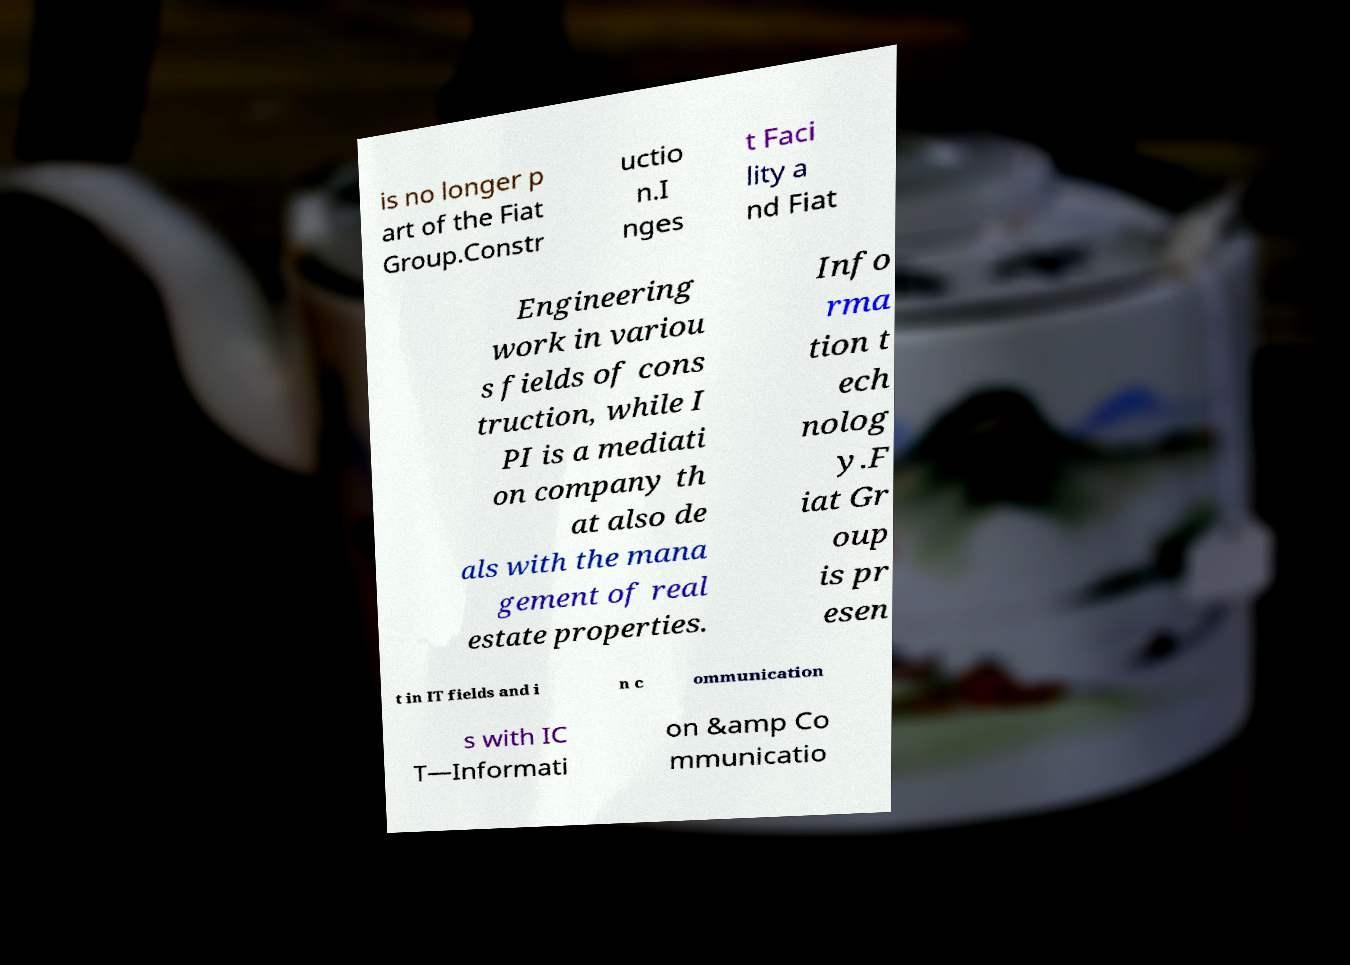Please read and relay the text visible in this image. What does it say? is no longer p art of the Fiat Group.Constr uctio n.I nges t Faci lity a nd Fiat Engineering work in variou s fields of cons truction, while I PI is a mediati on company th at also de als with the mana gement of real estate properties. Info rma tion t ech nolog y.F iat Gr oup is pr esen t in IT fields and i n c ommunication s with IC T—Informati on &amp Co mmunicatio 